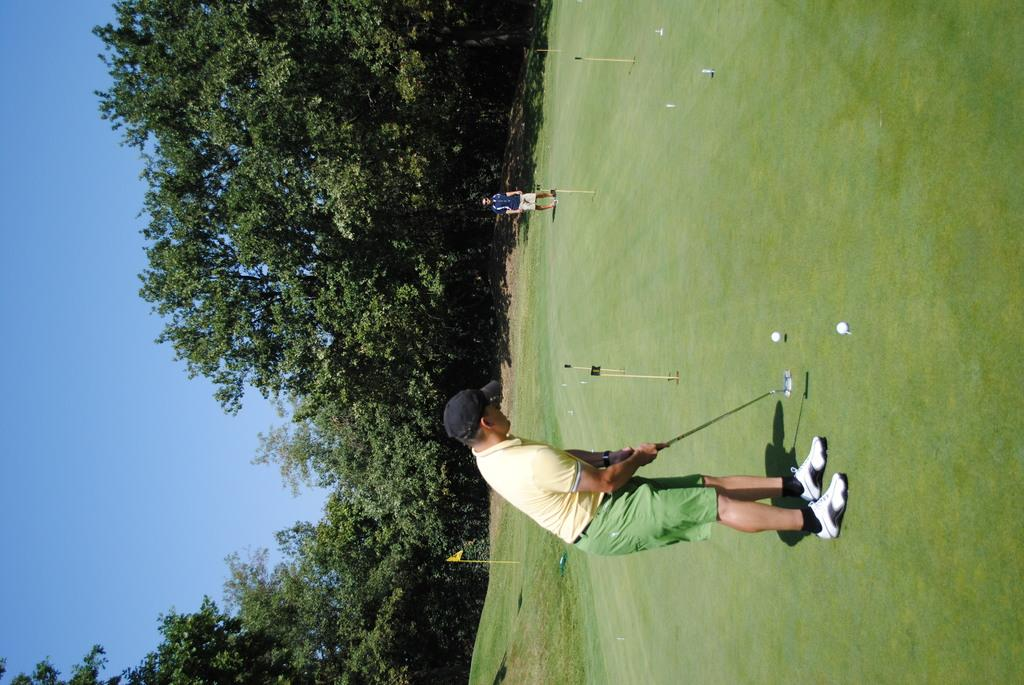What are the people in the image doing? The people are playing hockey. What can be seen in the background of the image? There are trees in the background of the image. What is the condition of the sky in the image? The sky is clear in the image. What type of meal is being prepared in the image? There is no meal preparation visible in the image; it features people playing hockey. What color is the coat worn by the person in the image? There is no person wearing a coat in the image; the people are dressed in hockey gear. 